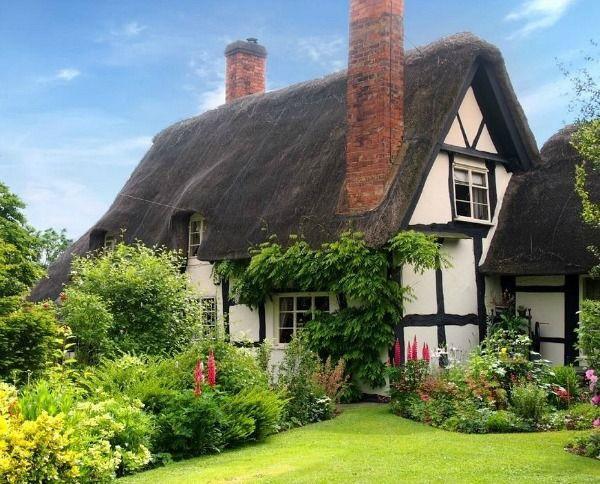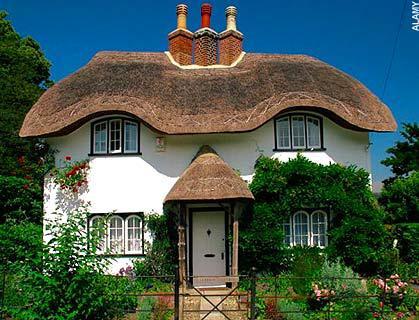The first image is the image on the left, the second image is the image on the right. For the images shown, is this caption "The left image shows a white house with bold dark lines on it forming geometric patterns, and a thatched roof with at least one notched cut-out for windows, and the right image shows a house with a thatched roof over the door and a roof over the house itself." true? Answer yes or no. Yes. 